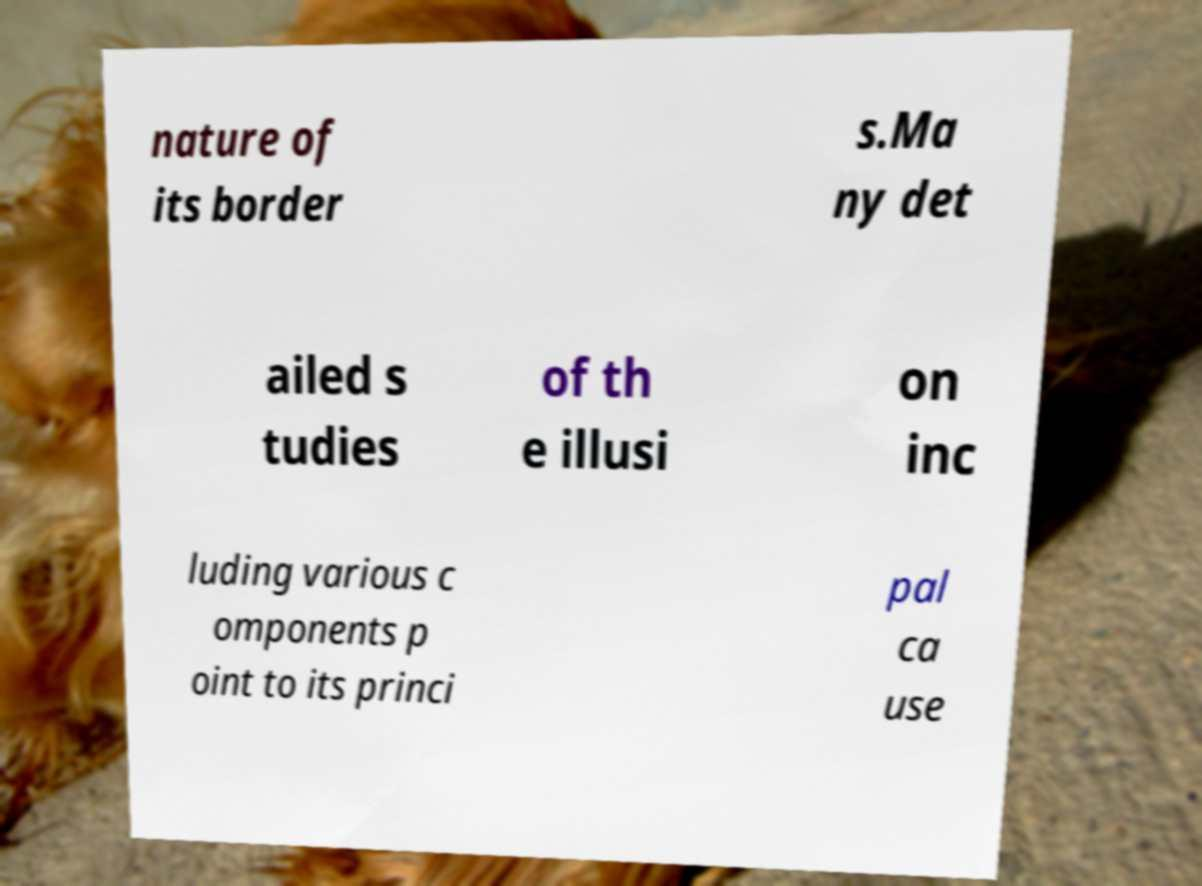Could you extract and type out the text from this image? nature of its border s.Ma ny det ailed s tudies of th e illusi on inc luding various c omponents p oint to its princi pal ca use 